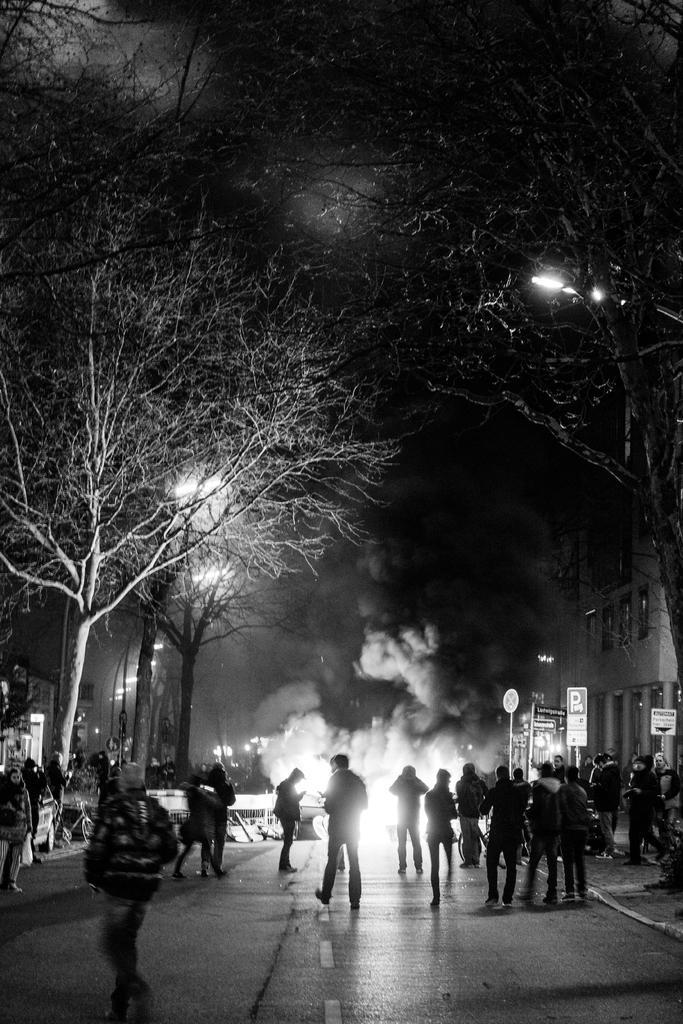Could you give a brief overview of what you see in this image? In this image we can see a few people on the road, trees, building, there are sign boards, light poles, vehicles, also we can see the sky. 